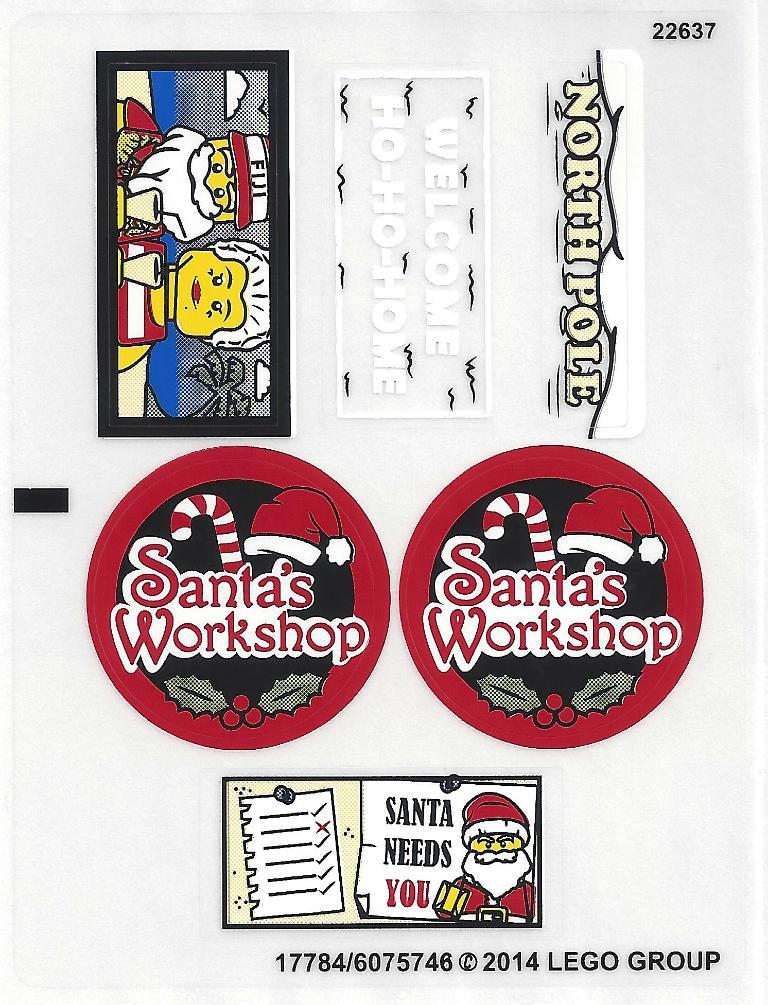What type of characters are present in the image? There are cartoon characters in the image. What else can be seen in the image besides the characters? There is text written in the image. What color is the background of the image? The background is white. What type of stem can be seen growing from the cartoon character's head in the image? There is no stem growing from any cartoon character's head in the image. 